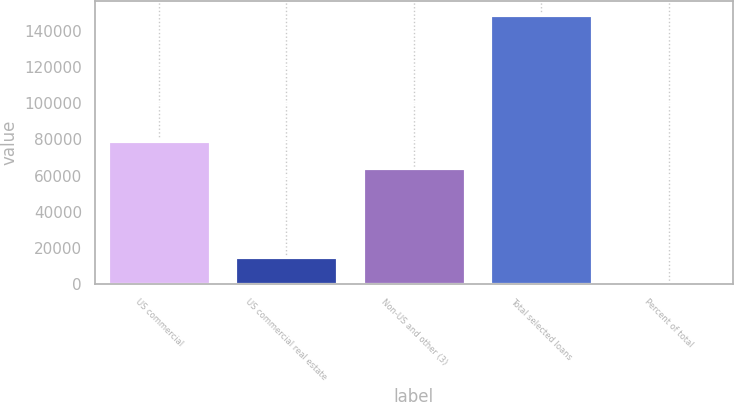Convert chart. <chart><loc_0><loc_0><loc_500><loc_500><bar_chart><fcel>US commercial<fcel>US commercial real estate<fcel>Non-US and other (3)<fcel>Total selected loans<fcel>Percent of total<nl><fcel>78986.3<fcel>14944.3<fcel>64078<fcel>149119<fcel>36<nl></chart> 